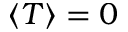Convert formula to latex. <formula><loc_0><loc_0><loc_500><loc_500>\left \langle T \right \rangle = 0</formula> 